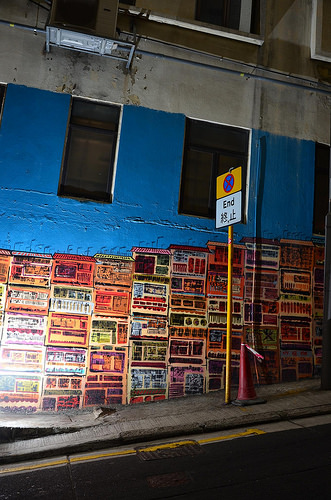<image>
Is the posters on the building? Yes. Looking at the image, I can see the posters is positioned on top of the building, with the building providing support. 